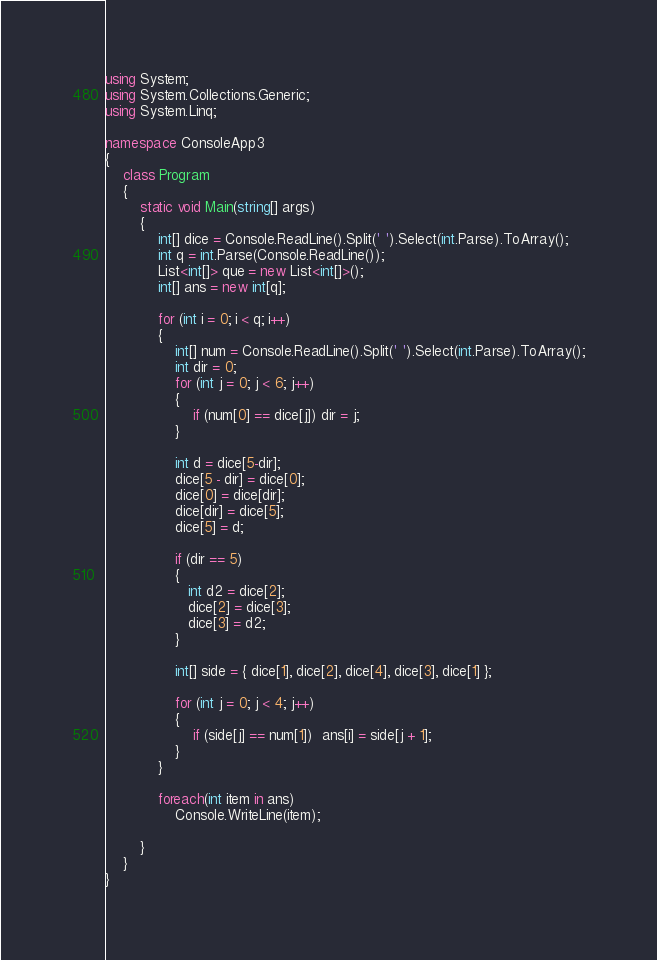<code> <loc_0><loc_0><loc_500><loc_500><_C#_>using System;
using System.Collections.Generic;
using System.Linq;

namespace ConsoleApp3
{
    class Program
    {
        static void Main(string[] args)
        {
            int[] dice = Console.ReadLine().Split(' ').Select(int.Parse).ToArray();
            int q = int.Parse(Console.ReadLine());
            List<int[]> que = new List<int[]>();
            int[] ans = new int[q];

            for (int i = 0; i < q; i++)
            {
                int[] num = Console.ReadLine().Split(' ').Select(int.Parse).ToArray();
                int dir = 0;
                for (int j = 0; j < 6; j++)
                {
                    if (num[0] == dice[j]) dir = j;
                }

                int d = dice[5-dir];
                dice[5 - dir] = dice[0];
                dice[0] = dice[dir];
                dice[dir] = dice[5];
                dice[5] = d;
                 
                if (dir == 5)
                {
                   int d2 = dice[2];
                   dice[2] = dice[3];
                   dice[3] = d2;
                }

                int[] side = { dice[1], dice[2], dice[4], dice[3], dice[1] };

                for (int j = 0; j < 4; j++)
                {
                    if (side[j] == num[1])  ans[i] = side[j + 1]; 
                }
            }
            
            foreach(int item in ans)
                Console.WriteLine(item);

        }
    }
}
</code> 